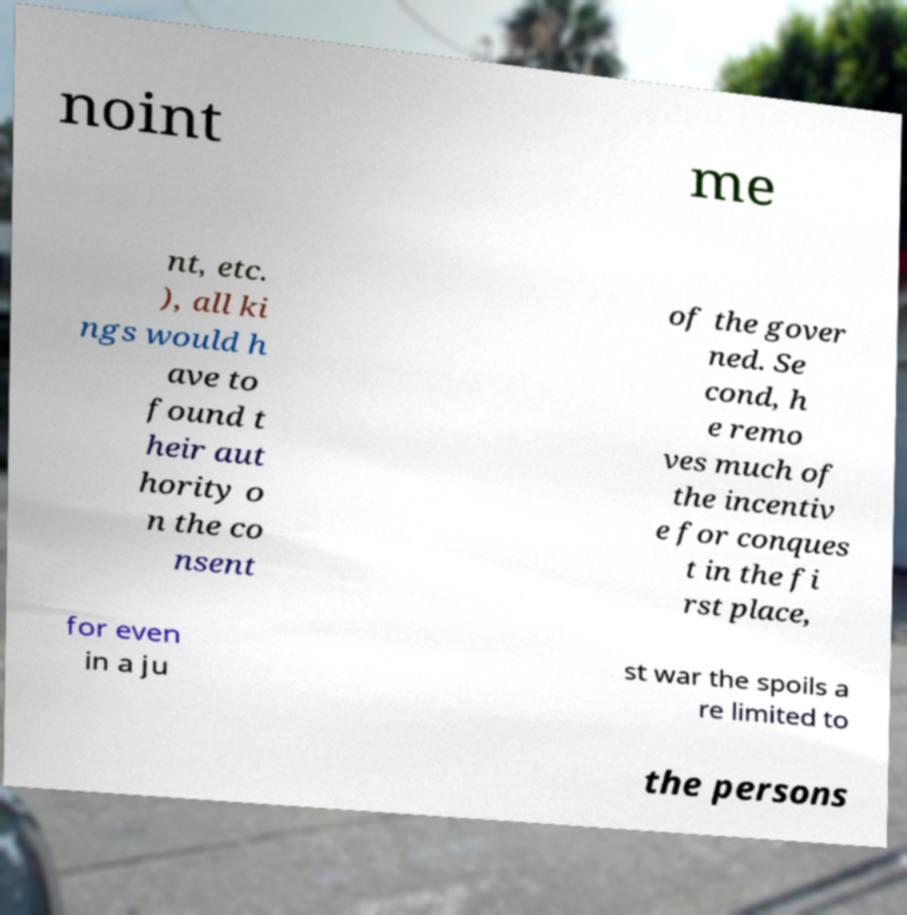What messages or text are displayed in this image? I need them in a readable, typed format. noint me nt, etc. ), all ki ngs would h ave to found t heir aut hority o n the co nsent of the gover ned. Se cond, h e remo ves much of the incentiv e for conques t in the fi rst place, for even in a ju st war the spoils a re limited to the persons 